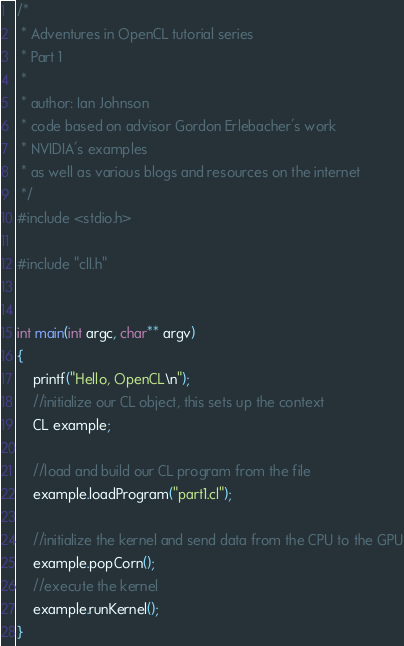Convert code to text. <code><loc_0><loc_0><loc_500><loc_500><_C++_>/*
 * Adventures in OpenCL tutorial series
 * Part 1
 *
 * author: Ian Johnson
 * code based on advisor Gordon Erlebacher's work
 * NVIDIA's examples
 * as well as various blogs and resources on the internet
 */
#include <stdio.h>

#include "cll.h"


int main(int argc, char** argv)
{
    printf("Hello, OpenCL\n");
    //initialize our CL object, this sets up the context
    CL example;
    
    //load and build our CL program from the file
    example.loadProgram("part1.cl");

    //initialize the kernel and send data from the CPU to the GPU
    example.popCorn();
    //execute the kernel
    example.runKernel();
}
</code> 